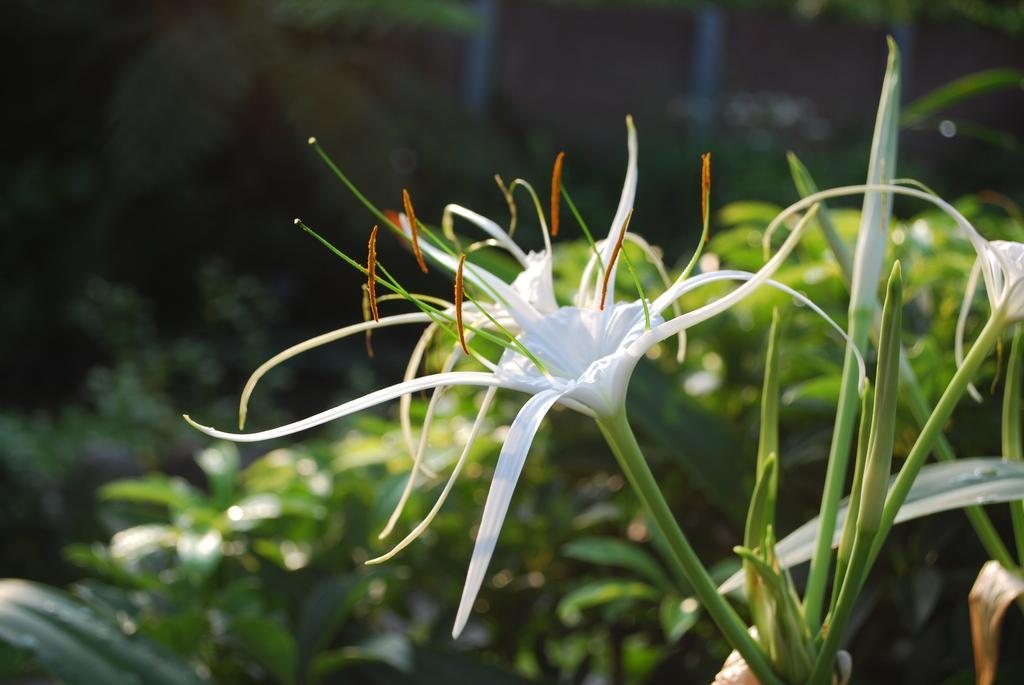Could you give a brief overview of what you see in this image? In this image we can see lily flowers and buds. In the background we can see leaves and it is blurry. 